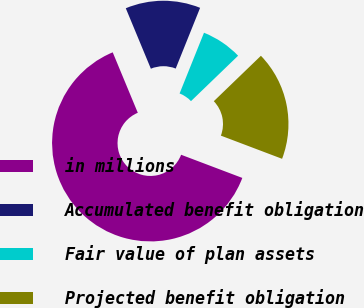<chart> <loc_0><loc_0><loc_500><loc_500><pie_chart><fcel>in millions<fcel>Accumulated benefit obligation<fcel>Fair value of plan assets<fcel>Projected benefit obligation<nl><fcel>62.98%<fcel>12.34%<fcel>6.71%<fcel>17.97%<nl></chart> 